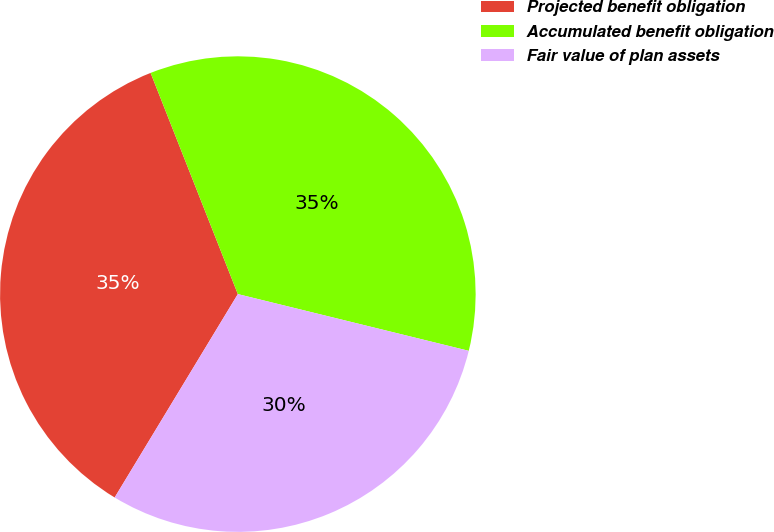Convert chart to OTSL. <chart><loc_0><loc_0><loc_500><loc_500><pie_chart><fcel>Projected benefit obligation<fcel>Accumulated benefit obligation<fcel>Fair value of plan assets<nl><fcel>35.35%<fcel>34.81%<fcel>29.83%<nl></chart> 